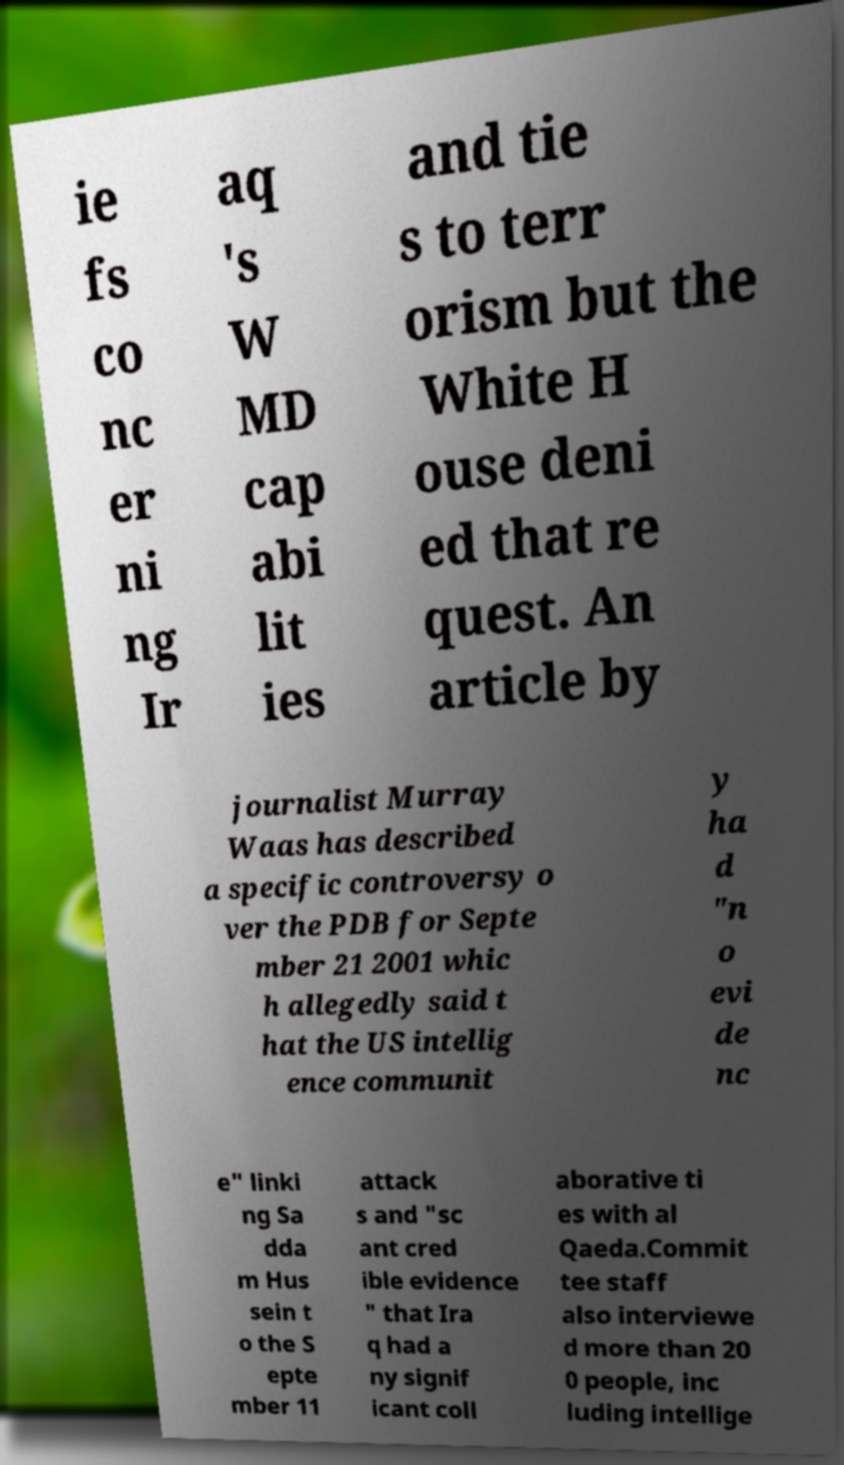There's text embedded in this image that I need extracted. Can you transcribe it verbatim? ie fs co nc er ni ng Ir aq 's W MD cap abi lit ies and tie s to terr orism but the White H ouse deni ed that re quest. An article by journalist Murray Waas has described a specific controversy o ver the PDB for Septe mber 21 2001 whic h allegedly said t hat the US intellig ence communit y ha d "n o evi de nc e" linki ng Sa dda m Hus sein t o the S epte mber 11 attack s and "sc ant cred ible evidence " that Ira q had a ny signif icant coll aborative ti es with al Qaeda.Commit tee staff also interviewe d more than 20 0 people, inc luding intellige 